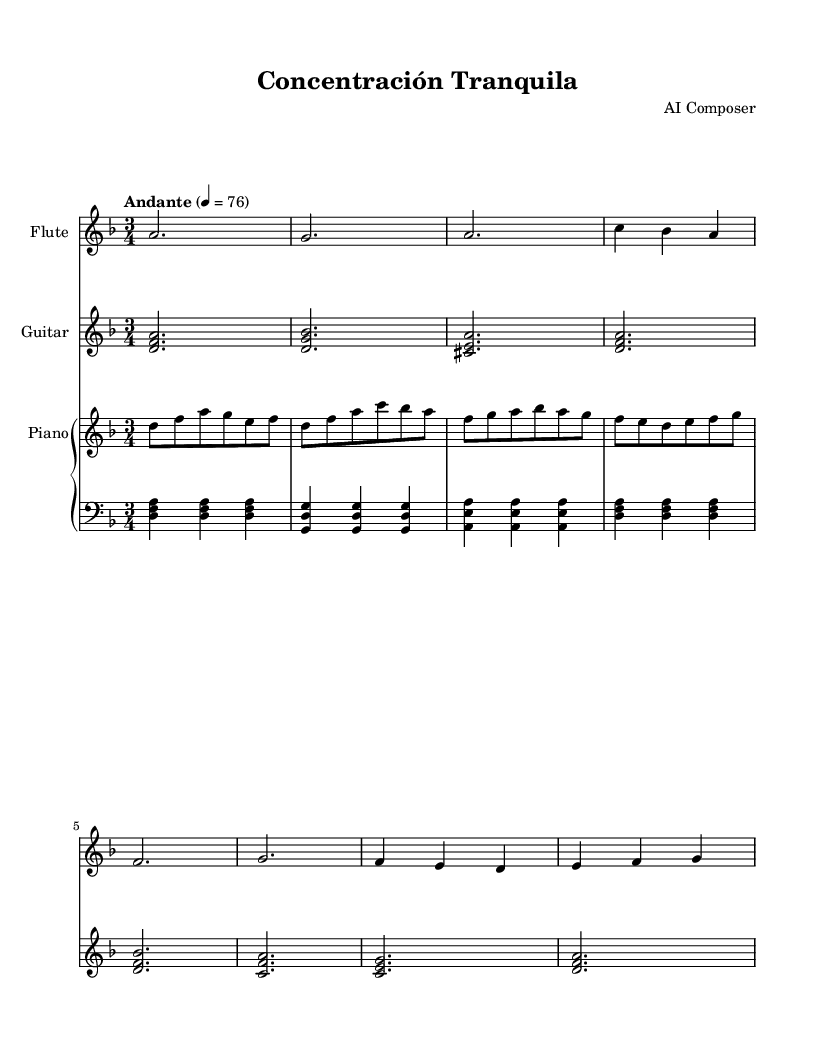What is the key signature of this music? The key signature is D minor, indicated by one flat (B flat) on the staff.
Answer: D minor What is the time signature of this piece? The time signature is 3/4, which shows that there are three beats in each measure.
Answer: 3/4 What is the tempo marking for this piece? The tempo marking is Andante, which indicates a moderate walking speed.
Answer: Andante How many instruments are present in the score? There are three instruments: Flute, Guitar, and Piano (in two staves: right and left).
Answer: Three Which instrument plays the lowest notes? The Piano left hand plays the lowest notes, as it uses the bass clef and contains lower pitches.
Answer: Piano (left) What type of harmony is used in the guitar part? The guitar part uses triads, where three notes are played simultaneously to create harmony.
Answer: Triads Is this piece likely to be considered suitable for background concentration? Yes, the calming tempo and smooth melodic lines make it suitable for concentration.
Answer: Yes 